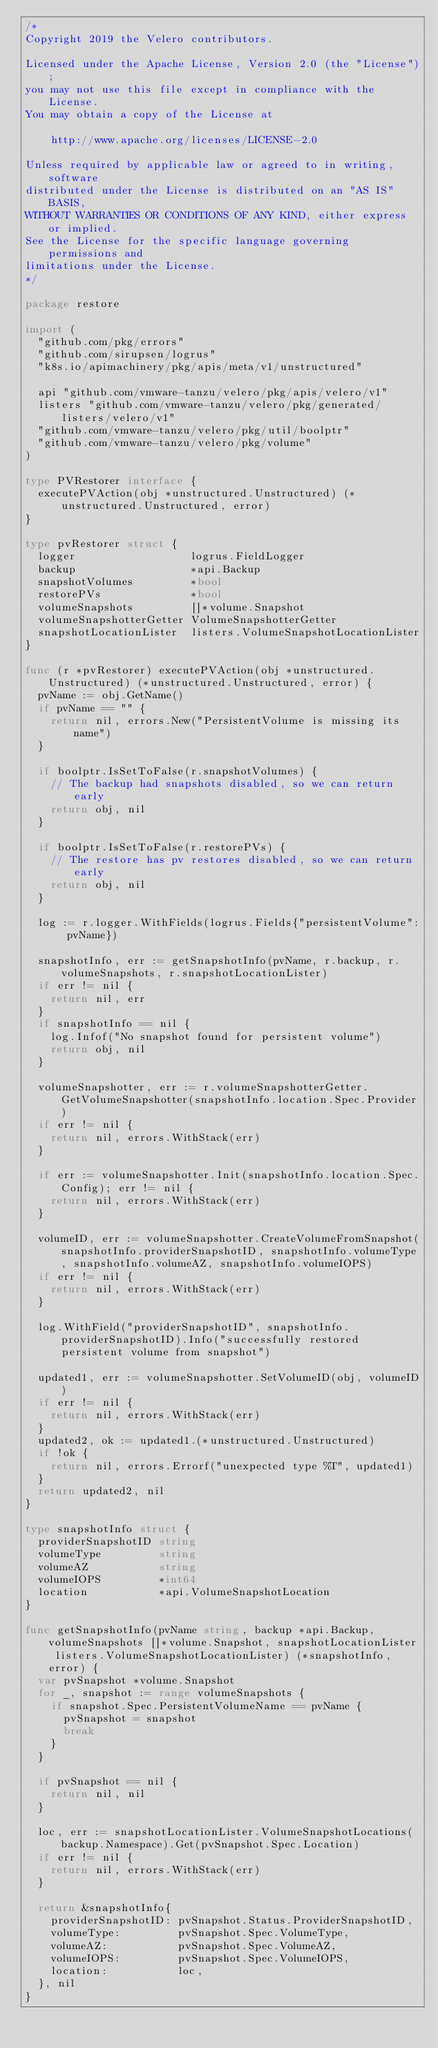Convert code to text. <code><loc_0><loc_0><loc_500><loc_500><_Go_>/*
Copyright 2019 the Velero contributors.

Licensed under the Apache License, Version 2.0 (the "License");
you may not use this file except in compliance with the License.
You may obtain a copy of the License at

    http://www.apache.org/licenses/LICENSE-2.0

Unless required by applicable law or agreed to in writing, software
distributed under the License is distributed on an "AS IS" BASIS,
WITHOUT WARRANTIES OR CONDITIONS OF ANY KIND, either express or implied.
See the License for the specific language governing permissions and
limitations under the License.
*/

package restore

import (
	"github.com/pkg/errors"
	"github.com/sirupsen/logrus"
	"k8s.io/apimachinery/pkg/apis/meta/v1/unstructured"

	api "github.com/vmware-tanzu/velero/pkg/apis/velero/v1"
	listers "github.com/vmware-tanzu/velero/pkg/generated/listers/velero/v1"
	"github.com/vmware-tanzu/velero/pkg/util/boolptr"
	"github.com/vmware-tanzu/velero/pkg/volume"
)

type PVRestorer interface {
	executePVAction(obj *unstructured.Unstructured) (*unstructured.Unstructured, error)
}

type pvRestorer struct {
	logger                  logrus.FieldLogger
	backup                  *api.Backup
	snapshotVolumes         *bool
	restorePVs              *bool
	volumeSnapshots         []*volume.Snapshot
	volumeSnapshotterGetter VolumeSnapshotterGetter
	snapshotLocationLister  listers.VolumeSnapshotLocationLister
}

func (r *pvRestorer) executePVAction(obj *unstructured.Unstructured) (*unstructured.Unstructured, error) {
	pvName := obj.GetName()
	if pvName == "" {
		return nil, errors.New("PersistentVolume is missing its name")
	}

	if boolptr.IsSetToFalse(r.snapshotVolumes) {
		// The backup had snapshots disabled, so we can return early
		return obj, nil
	}

	if boolptr.IsSetToFalse(r.restorePVs) {
		// The restore has pv restores disabled, so we can return early
		return obj, nil
	}

	log := r.logger.WithFields(logrus.Fields{"persistentVolume": pvName})

	snapshotInfo, err := getSnapshotInfo(pvName, r.backup, r.volumeSnapshots, r.snapshotLocationLister)
	if err != nil {
		return nil, err
	}
	if snapshotInfo == nil {
		log.Infof("No snapshot found for persistent volume")
		return obj, nil
	}

	volumeSnapshotter, err := r.volumeSnapshotterGetter.GetVolumeSnapshotter(snapshotInfo.location.Spec.Provider)
	if err != nil {
		return nil, errors.WithStack(err)
	}

	if err := volumeSnapshotter.Init(snapshotInfo.location.Spec.Config); err != nil {
		return nil, errors.WithStack(err)
	}

	volumeID, err := volumeSnapshotter.CreateVolumeFromSnapshot(snapshotInfo.providerSnapshotID, snapshotInfo.volumeType, snapshotInfo.volumeAZ, snapshotInfo.volumeIOPS)
	if err != nil {
		return nil, errors.WithStack(err)
	}

	log.WithField("providerSnapshotID", snapshotInfo.providerSnapshotID).Info("successfully restored persistent volume from snapshot")

	updated1, err := volumeSnapshotter.SetVolumeID(obj, volumeID)
	if err != nil {
		return nil, errors.WithStack(err)
	}
	updated2, ok := updated1.(*unstructured.Unstructured)
	if !ok {
		return nil, errors.Errorf("unexpected type %T", updated1)
	}
	return updated2, nil
}

type snapshotInfo struct {
	providerSnapshotID string
	volumeType         string
	volumeAZ           string
	volumeIOPS         *int64
	location           *api.VolumeSnapshotLocation
}

func getSnapshotInfo(pvName string, backup *api.Backup, volumeSnapshots []*volume.Snapshot, snapshotLocationLister listers.VolumeSnapshotLocationLister) (*snapshotInfo, error) {
	var pvSnapshot *volume.Snapshot
	for _, snapshot := range volumeSnapshots {
		if snapshot.Spec.PersistentVolumeName == pvName {
			pvSnapshot = snapshot
			break
		}
	}

	if pvSnapshot == nil {
		return nil, nil
	}

	loc, err := snapshotLocationLister.VolumeSnapshotLocations(backup.Namespace).Get(pvSnapshot.Spec.Location)
	if err != nil {
		return nil, errors.WithStack(err)
	}

	return &snapshotInfo{
		providerSnapshotID: pvSnapshot.Status.ProviderSnapshotID,
		volumeType:         pvSnapshot.Spec.VolumeType,
		volumeAZ:           pvSnapshot.Spec.VolumeAZ,
		volumeIOPS:         pvSnapshot.Spec.VolumeIOPS,
		location:           loc,
	}, nil
}
</code> 